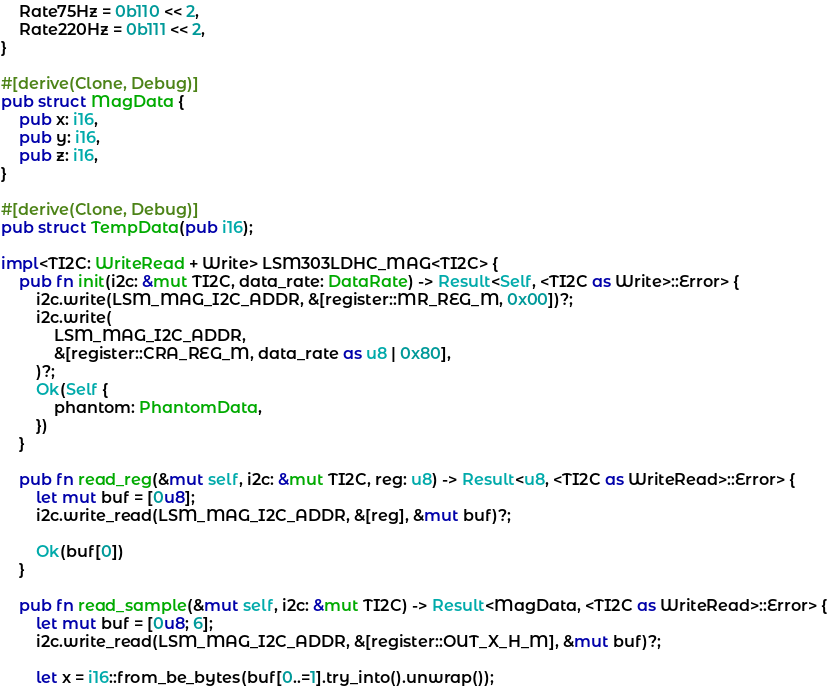Convert code to text. <code><loc_0><loc_0><loc_500><loc_500><_Rust_>    Rate75Hz = 0b110 << 2,
    Rate220Hz = 0b111 << 2,
}

#[derive(Clone, Debug)]
pub struct MagData {
    pub x: i16,
    pub y: i16,
    pub z: i16,
}

#[derive(Clone, Debug)]
pub struct TempData(pub i16);

impl<TI2C: WriteRead + Write> LSM303LDHC_MAG<TI2C> {
    pub fn init(i2c: &mut TI2C, data_rate: DataRate) -> Result<Self, <TI2C as Write>::Error> {
        i2c.write(LSM_MAG_I2C_ADDR, &[register::MR_REG_M, 0x00])?;
        i2c.write(
            LSM_MAG_I2C_ADDR,
            &[register::CRA_REG_M, data_rate as u8 | 0x80],
        )?;
        Ok(Self {
            phantom: PhantomData,
        })
    }

    pub fn read_reg(&mut self, i2c: &mut TI2C, reg: u8) -> Result<u8, <TI2C as WriteRead>::Error> {
        let mut buf = [0u8];
        i2c.write_read(LSM_MAG_I2C_ADDR, &[reg], &mut buf)?;

        Ok(buf[0])
    }

    pub fn read_sample(&mut self, i2c: &mut TI2C) -> Result<MagData, <TI2C as WriteRead>::Error> {
        let mut buf = [0u8; 6];
        i2c.write_read(LSM_MAG_I2C_ADDR, &[register::OUT_X_H_M], &mut buf)?;

        let x = i16::from_be_bytes(buf[0..=1].try_into().unwrap());</code> 